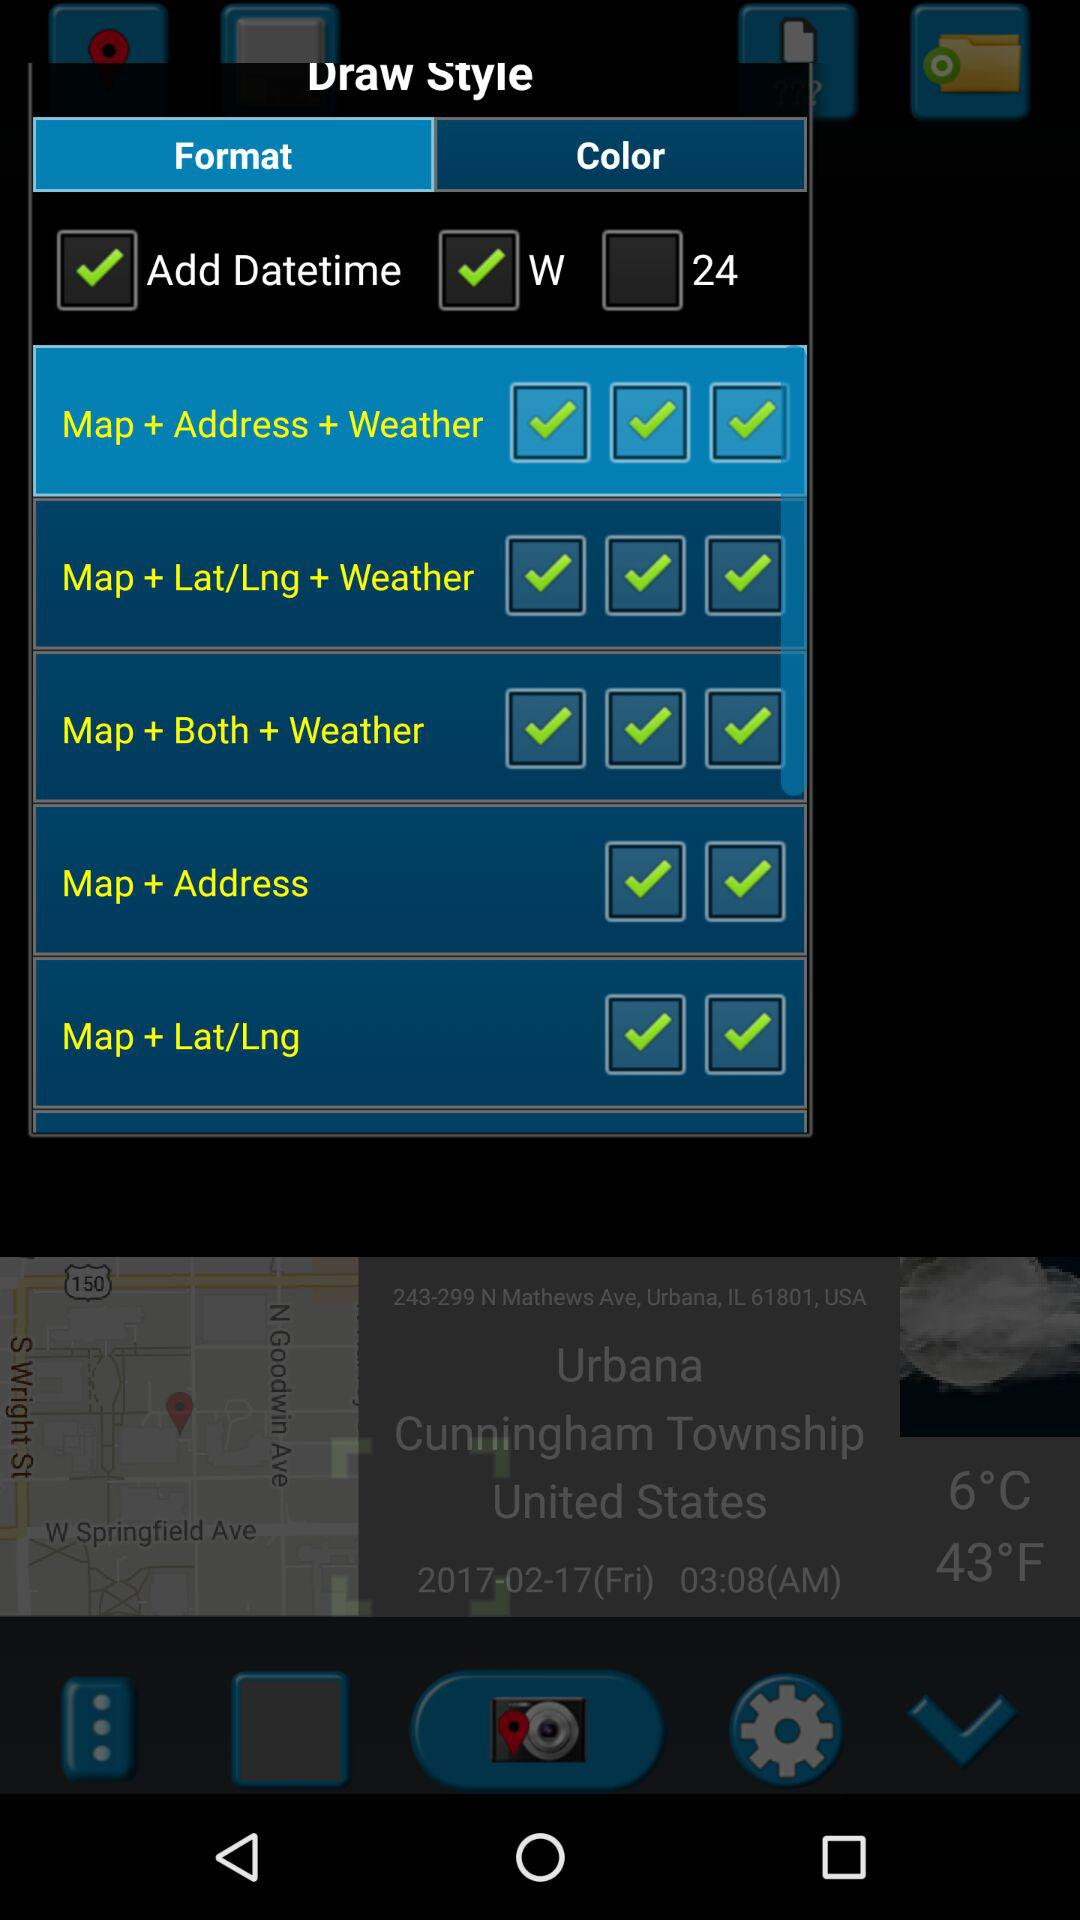What is the status of "Add Datetime"? The status is "on". 